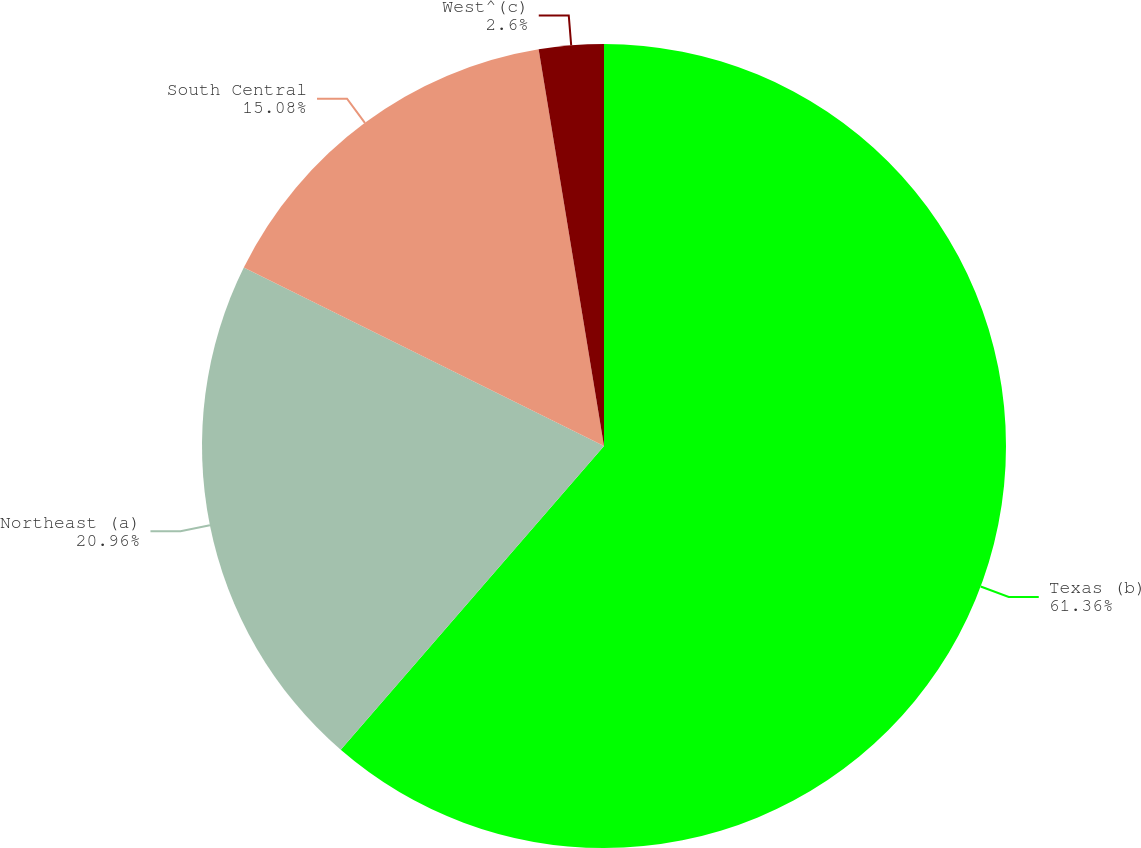Convert chart. <chart><loc_0><loc_0><loc_500><loc_500><pie_chart><fcel>Texas (b)<fcel>Northeast (a)<fcel>South Central<fcel>West^(c)<nl><fcel>61.37%<fcel>20.96%<fcel>15.08%<fcel>2.6%<nl></chart> 